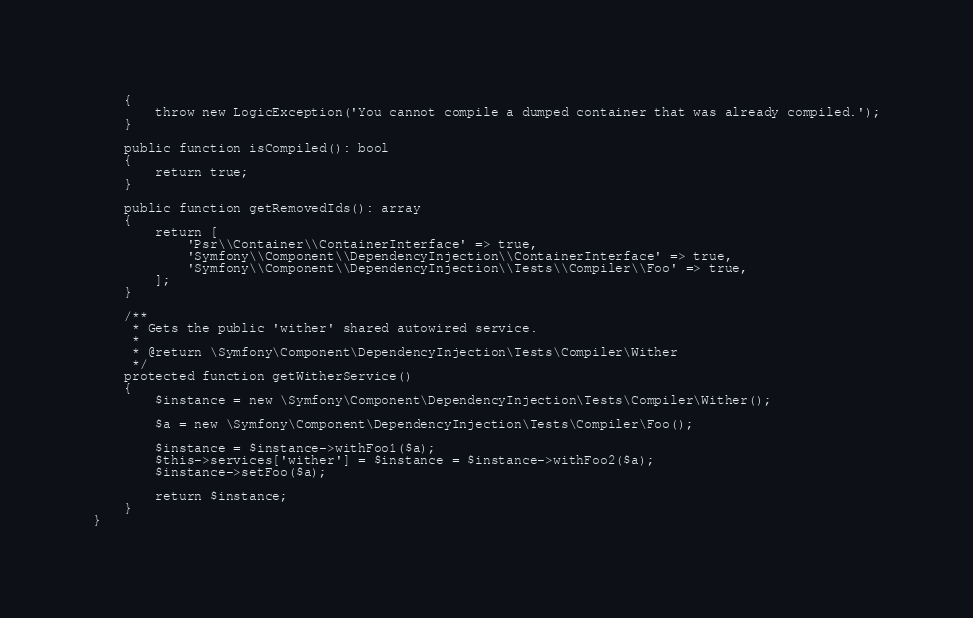<code> <loc_0><loc_0><loc_500><loc_500><_PHP_>    {
        throw new LogicException('You cannot compile a dumped container that was already compiled.');
    }

    public function isCompiled(): bool
    {
        return true;
    }

    public function getRemovedIds(): array
    {
        return [
            'Psr\\Container\\ContainerInterface' => true,
            'Symfony\\Component\\DependencyInjection\\ContainerInterface' => true,
            'Symfony\\Component\\DependencyInjection\\Tests\\Compiler\\Foo' => true,
        ];
    }

    /**
     * Gets the public 'wither' shared autowired service.
     *
     * @return \Symfony\Component\DependencyInjection\Tests\Compiler\Wither
     */
    protected function getWitherService()
    {
        $instance = new \Symfony\Component\DependencyInjection\Tests\Compiler\Wither();

        $a = new \Symfony\Component\DependencyInjection\Tests\Compiler\Foo();

        $instance = $instance->withFoo1($a);
        $this->services['wither'] = $instance = $instance->withFoo2($a);
        $instance->setFoo($a);

        return $instance;
    }
}
</code> 